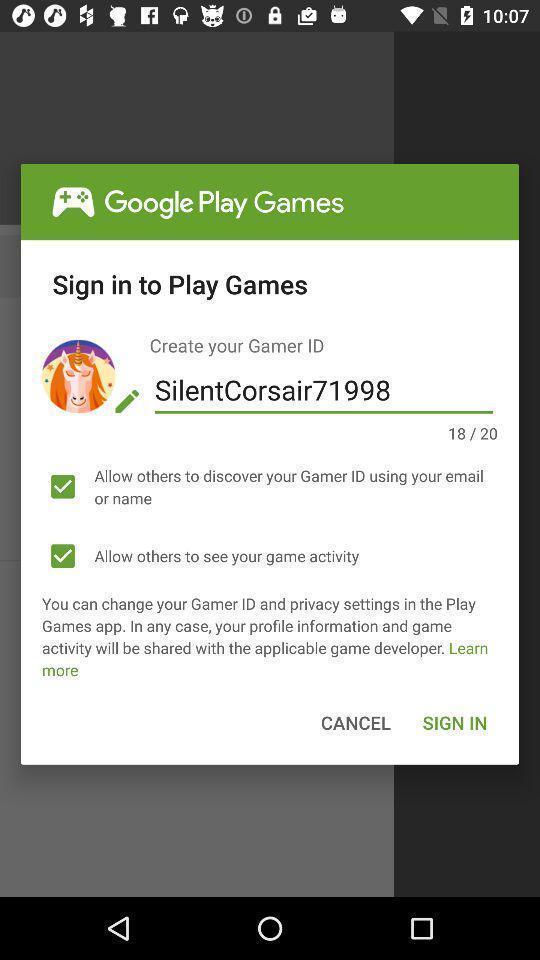Provide a description of this screenshot. Pop-up to create your identification. 